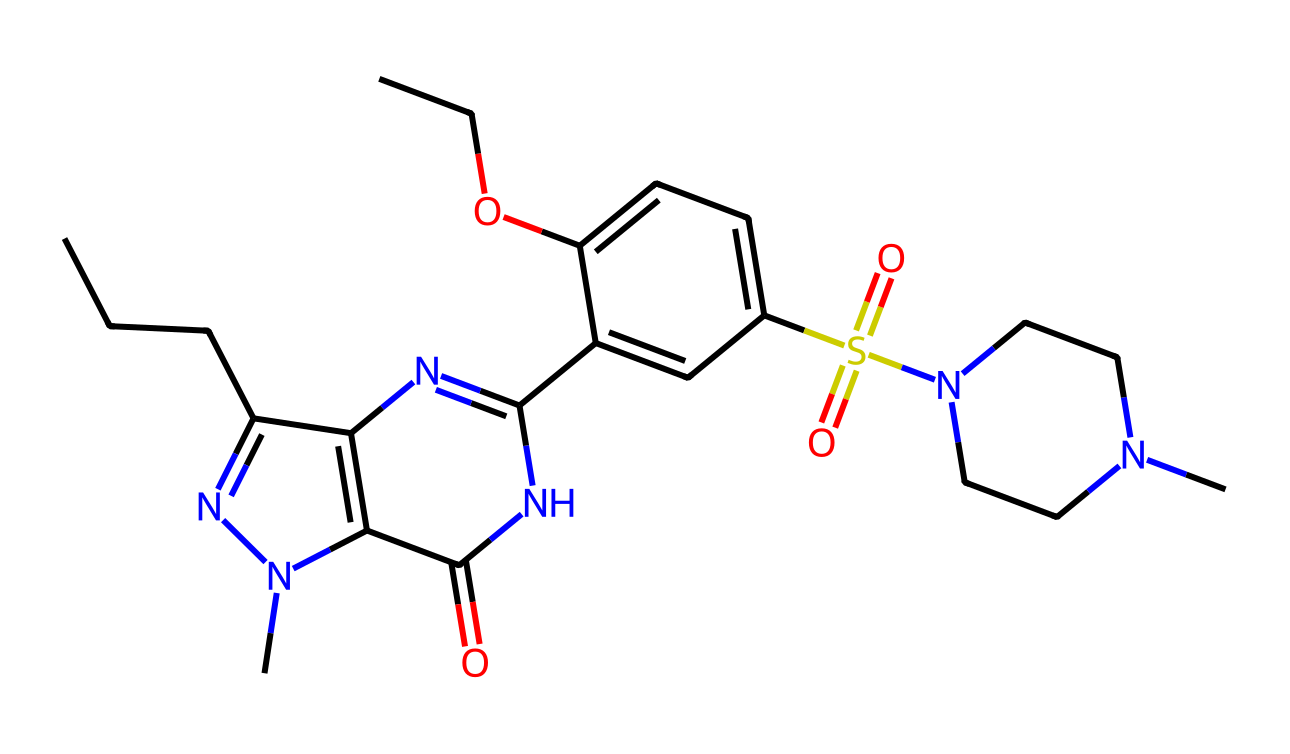What is the molecular formula of sildenafil? By analyzing the SMILES representation, we can count the atoms of each element present. The total composition is C22, H30, N6, O3, and S.
Answer: C22H30N6O3S How many nitrogen atoms are present in the structure? In the SMILES representation, we can see the presence of multiple 'N' symbols, indicating nitrogen. Counting them reveals there are six nitrogen atoms in total.
Answer: 6 What functional group can be identified in sildenafil? The presence of the sulfonamide group, characterized by the "S(=O)(=O)N" in the structure, indicates this functional group is present.
Answer: sulfonamide Does sildenafil have any aromatic rings? Observing the structure, we identify several cyclic structures containing alternating double bonds, fulfilling the criteria for aromatic systems. This indicates the presence of one or more aromatic rings.
Answer: yes What type of drug is sildenafil classified as? Given its pharmacological action that aids in treating erectile dysfunction, sildenafil is classified as a phosphodiesterase type 5 inhibitor.
Answer: PDE5 inhibitor What is the significance of the hydroxyl (–OH) group in sildenafil? The OH group contributes to the solubility and polarity of sildenafil, which is significant for its absorption and bioavailability in the body.
Answer: solubility How many total rings are present in the molecular structure? By examining the cyclic portions of the SMILES representation, specifically noting the numbered sections in the rings, we can ascertain that there are three distinct rings present in the structure.
Answer: 3 